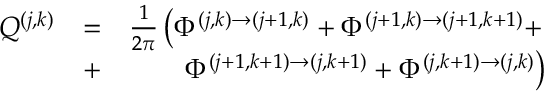Convert formula to latex. <formula><loc_0><loc_0><loc_500><loc_500>\begin{array} { r l r } { Q ^ { ( j , k ) } } & { = } & { \frac { 1 } { 2 \pi } \left ( \Phi ^ { ( j , k ) \rightarrow ( j + 1 , k ) } + \Phi ^ { ( j + 1 , k ) \rightarrow ( j + 1 , k + 1 ) } + } \\ & { + } & { \Phi ^ { ( j + 1 , k + 1 ) \rightarrow ( j , k + 1 ) } + \Phi ^ { ( j , k + 1 ) \rightarrow ( j , k ) } \right ) } \end{array}</formula> 